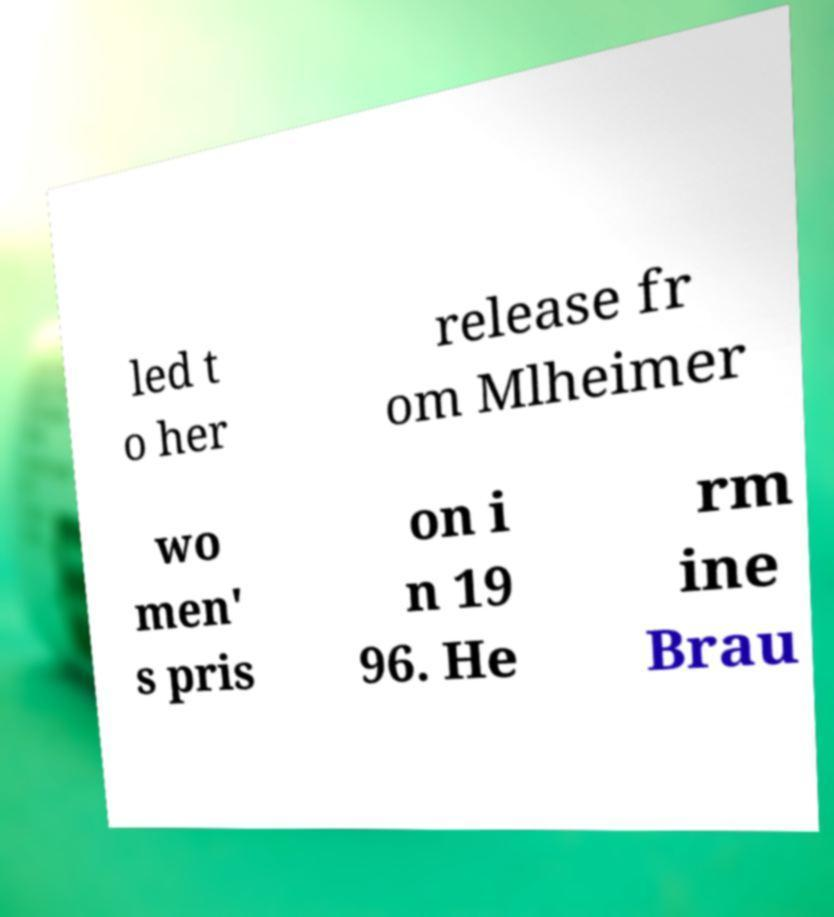I need the written content from this picture converted into text. Can you do that? led t o her release fr om Mlheimer wo men' s pris on i n 19 96. He rm ine Brau 